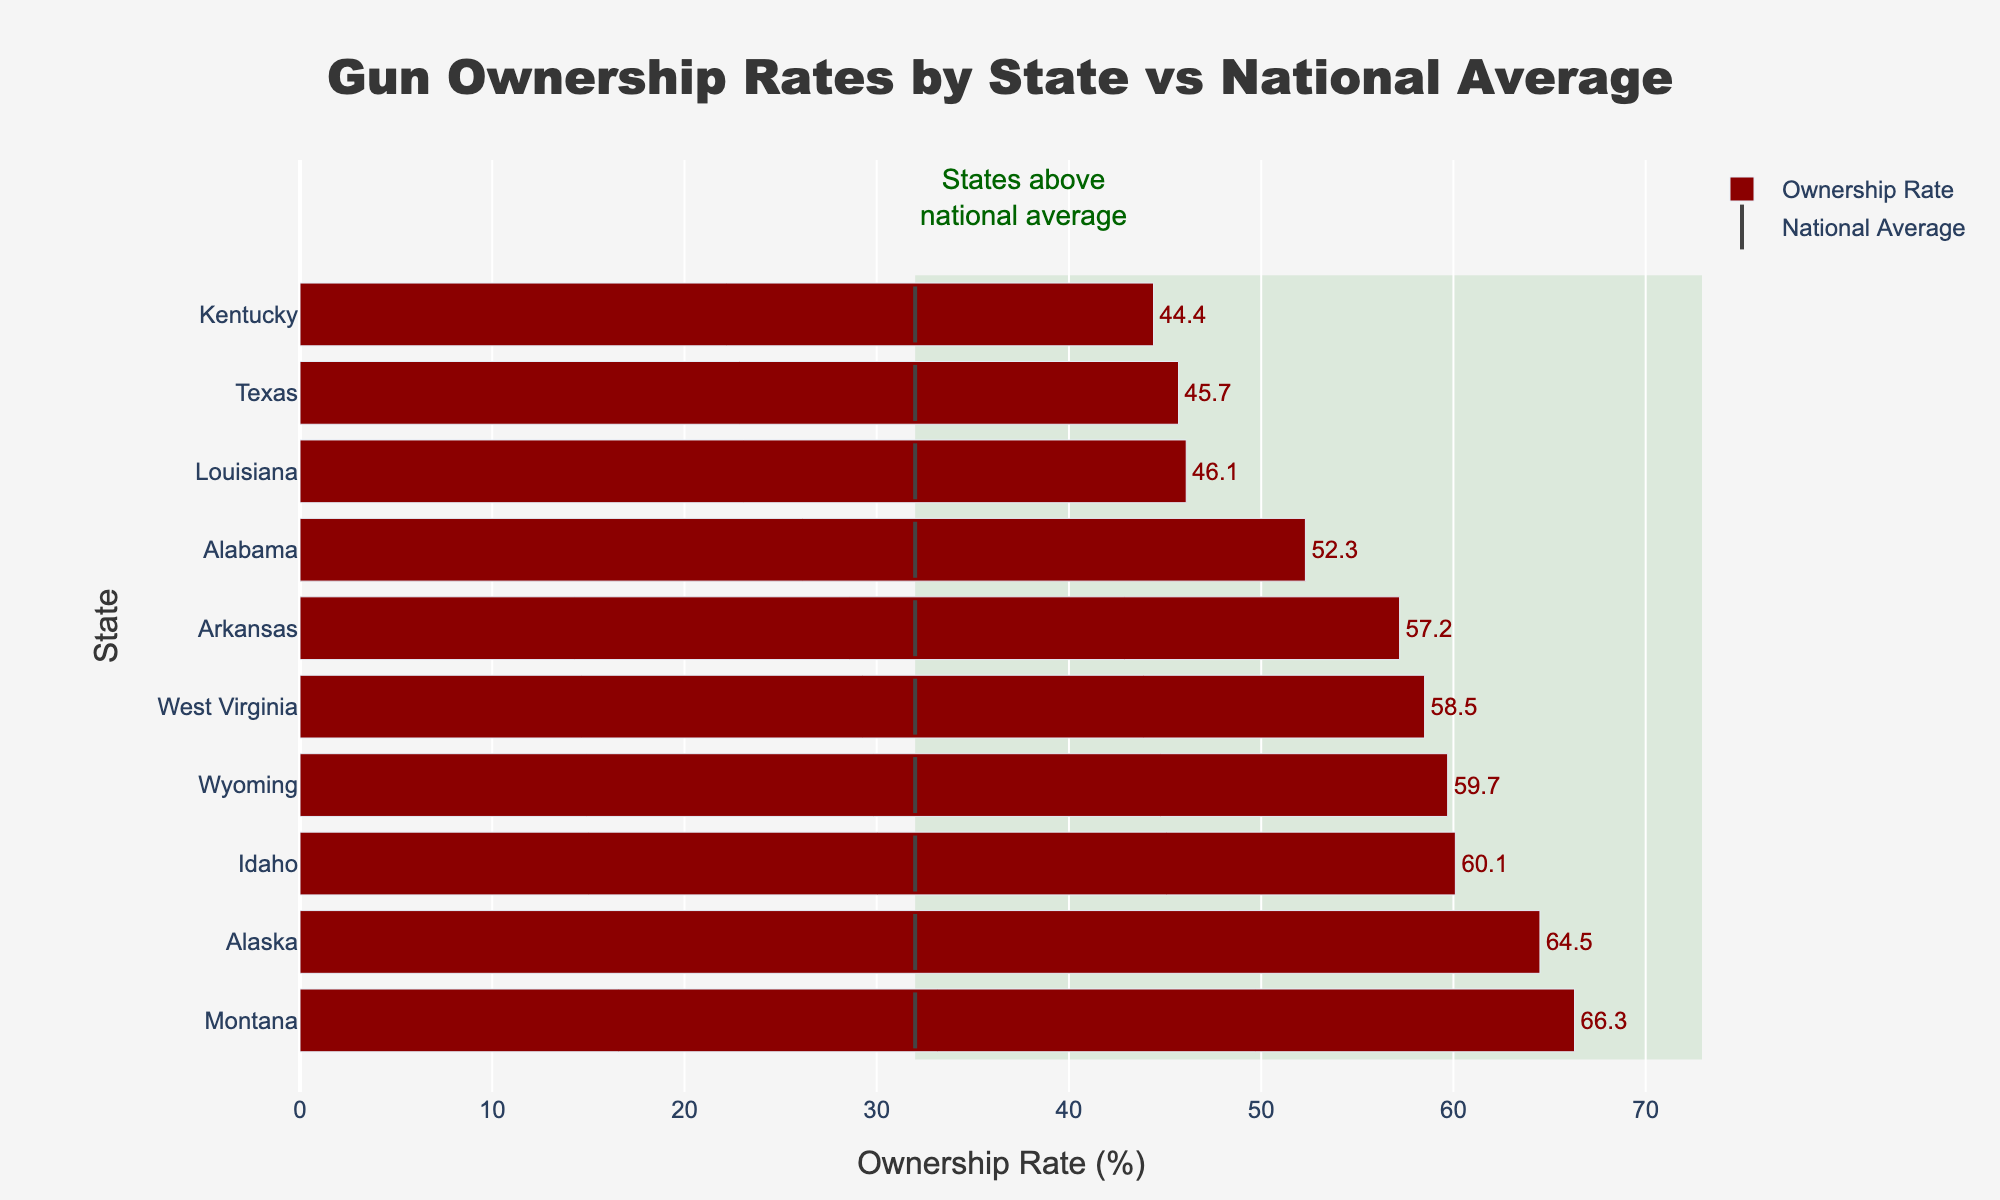What is the title of the chart? The title is displayed at the top of the chart.
Answer: Gun Ownership Rates by State vs National Average Which state has the highest gun ownership rate? The bar representing each state's ownership rate shows Montana at the top.
Answer: Montana How many states have gun ownership rates above the national average? The national average is marked at 32% and there are 10 bars to the right of this mark.
Answer: 10 Which state has the lowest gun ownership rate among those listed? By looking at the bar lengths from shortest to longest, Kentucky has the shortest bar.
Answer: Kentucky What is the difference in gun ownership rate between Montana and the national average? Subtract the national average (32%) from Montana’s rate (66.3%).
Answer: 34.3% How does Texas' gun ownership rate compare to Louisiana's? Compare the bar lengths for Texas (45.7%) and Louisiana (46.1%).
Answer: Slightly lower What's the average gun ownership rate for the states listed? Sum all ownership rates and divide by the number of states: (45.7 + 52.3 + 66.3 + 59.7 + 60.1 + 44.4 + 64.5 + 57.2 + 58.5 + 46.1) / 10.
Answer: 55.5% Which states have gun ownership rates above 50%? Identify the bars that exceed the 50% mark: Alabama (52.3%), Montana (66.3%), Wyoming (59.7%), Idaho (60.1%), Alaska (64.5%), Arkansas (57.2%), and West Virginia (58.5%).
Answer: Alabama, Montana, Wyoming, Idaho, Alaska, Arkansas, West Virginia What's the median gun ownership rate for the states listed? Organize the ownership rates in ascending order and find the middle value(s). The middle values are the 5th and 6th values (52.3% and 57.2%), so the median is their average.
Answer: 55.0% Are there any states with gun ownership rates more than double the national average? A rate more than double 32% is 64%. Check if any bars exceed this: Montana (66.3%) and Alaska (64.5%).
Answer: Yes, Montana 